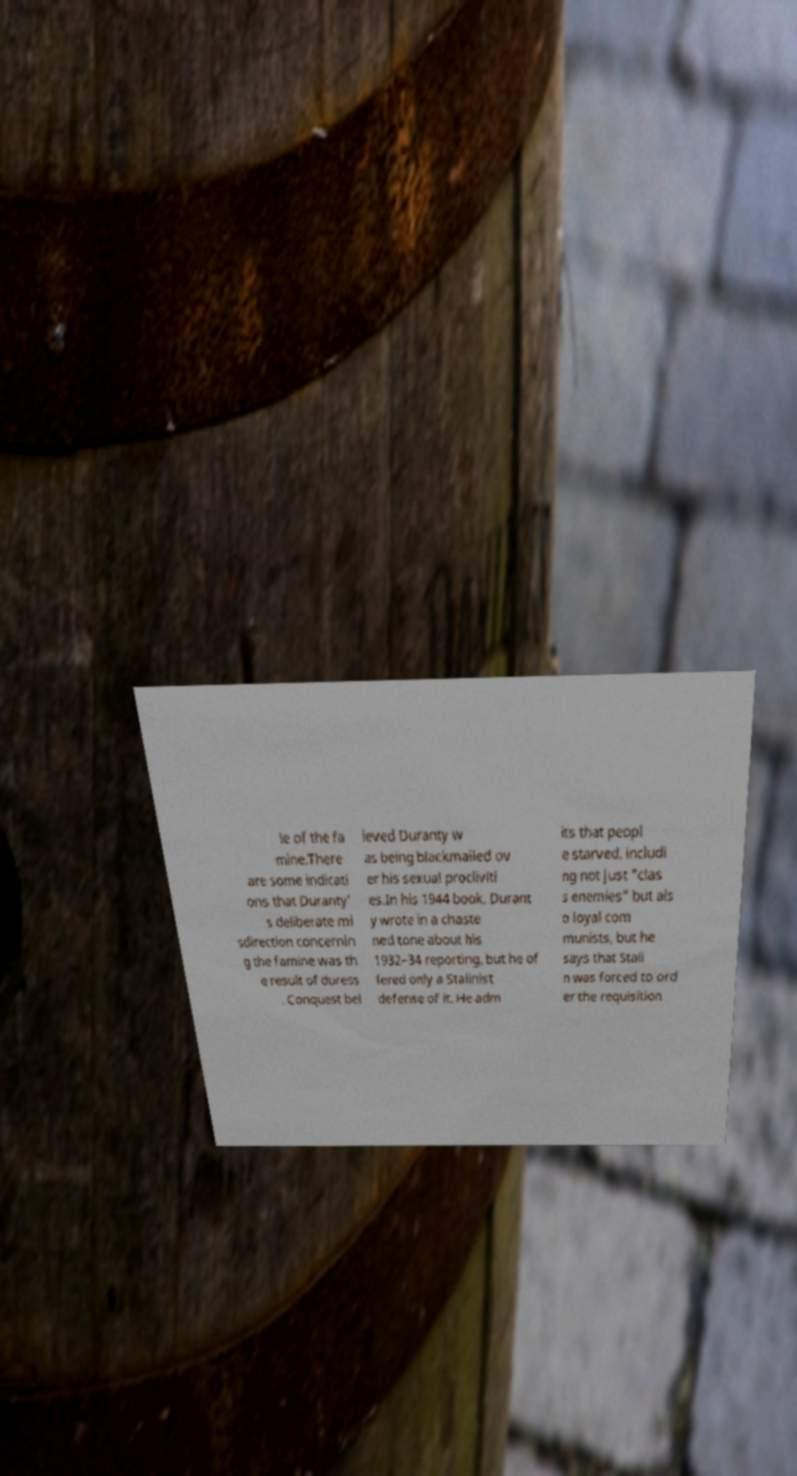What messages or text are displayed in this image? I need them in a readable, typed format. le of the fa mine.There are some indicati ons that Duranty' s deliberate mi sdirection concernin g the famine was th e result of duress . Conquest bel ieved Duranty w as being blackmailed ov er his sexual procliviti es.In his 1944 book, Durant y wrote in a chaste ned tone about his 1932–34 reporting, but he of fered only a Stalinist defense of it. He adm its that peopl e starved, includi ng not just "clas s enemies" but als o loyal com munists, but he says that Stali n was forced to ord er the requisition 